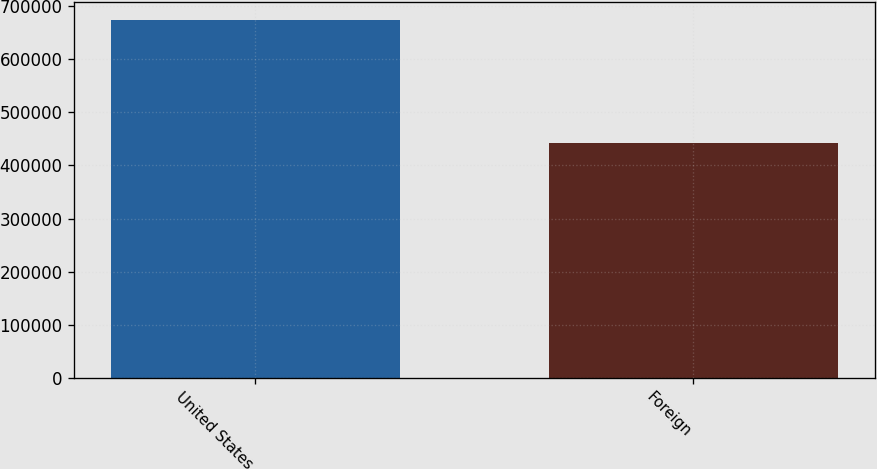Convert chart to OTSL. <chart><loc_0><loc_0><loc_500><loc_500><bar_chart><fcel>United States<fcel>Foreign<nl><fcel>672907<fcel>441821<nl></chart> 